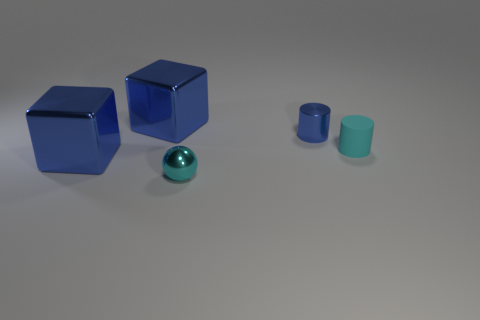Add 5 big blue shiny blocks. How many objects exist? 10 Subtract all balls. How many objects are left? 4 Subtract all yellow matte cylinders. Subtract all blue shiny cylinders. How many objects are left? 4 Add 3 tiny objects. How many tiny objects are left? 6 Add 4 tiny shiny blocks. How many tiny shiny blocks exist? 4 Subtract 0 purple cubes. How many objects are left? 5 